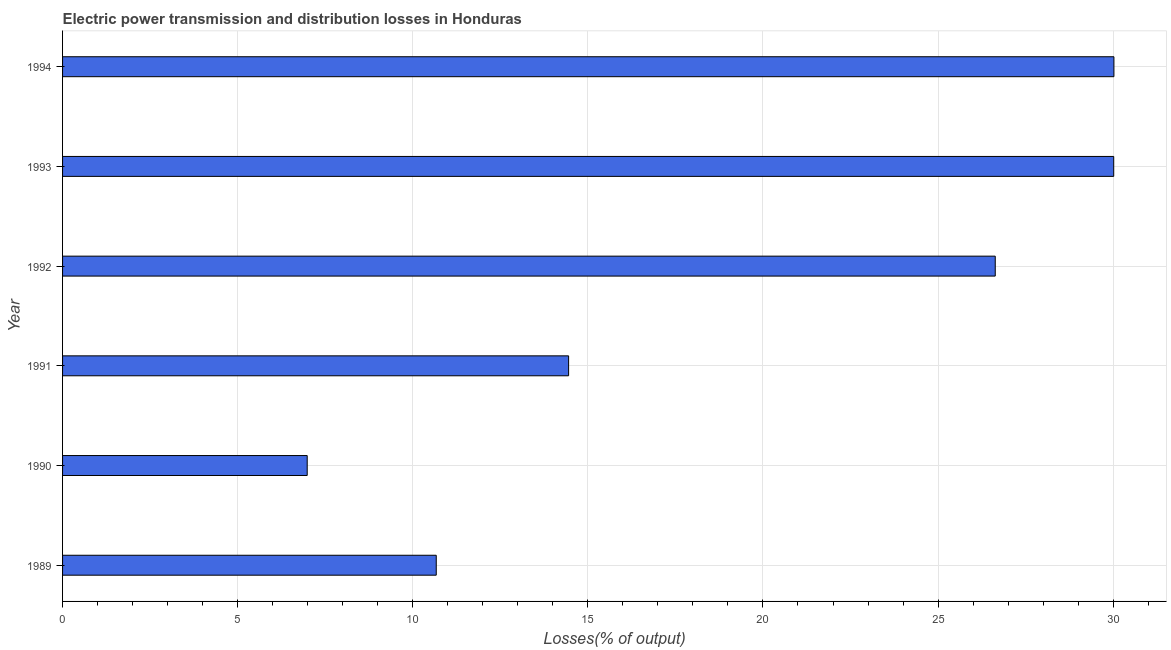Does the graph contain grids?
Offer a very short reply. Yes. What is the title of the graph?
Ensure brevity in your answer.  Electric power transmission and distribution losses in Honduras. What is the label or title of the X-axis?
Your answer should be compact. Losses(% of output). What is the label or title of the Y-axis?
Keep it short and to the point. Year. What is the electric power transmission and distribution losses in 1993?
Make the answer very short. 30.02. Across all years, what is the maximum electric power transmission and distribution losses?
Offer a very short reply. 30.02. Across all years, what is the minimum electric power transmission and distribution losses?
Give a very brief answer. 6.99. In which year was the electric power transmission and distribution losses maximum?
Your response must be concise. 1994. What is the sum of the electric power transmission and distribution losses?
Your response must be concise. 118.78. What is the difference between the electric power transmission and distribution losses in 1990 and 1994?
Your response must be concise. -23.04. What is the average electric power transmission and distribution losses per year?
Your answer should be very brief. 19.8. What is the median electric power transmission and distribution losses?
Keep it short and to the point. 20.54. In how many years, is the electric power transmission and distribution losses greater than 1 %?
Your answer should be very brief. 6. What is the ratio of the electric power transmission and distribution losses in 1991 to that in 1992?
Give a very brief answer. 0.54. Is the difference between the electric power transmission and distribution losses in 1992 and 1993 greater than the difference between any two years?
Give a very brief answer. No. What is the difference between the highest and the second highest electric power transmission and distribution losses?
Offer a terse response. 0.01. Is the sum of the electric power transmission and distribution losses in 1989 and 1994 greater than the maximum electric power transmission and distribution losses across all years?
Keep it short and to the point. Yes. What is the difference between the highest and the lowest electric power transmission and distribution losses?
Offer a terse response. 23.04. In how many years, is the electric power transmission and distribution losses greater than the average electric power transmission and distribution losses taken over all years?
Make the answer very short. 3. How many bars are there?
Keep it short and to the point. 6. Are all the bars in the graph horizontal?
Your answer should be compact. Yes. What is the difference between two consecutive major ticks on the X-axis?
Offer a very short reply. 5. What is the Losses(% of output) of 1989?
Offer a terse response. 10.67. What is the Losses(% of output) in 1990?
Keep it short and to the point. 6.99. What is the Losses(% of output) in 1991?
Offer a very short reply. 14.45. What is the Losses(% of output) of 1992?
Offer a terse response. 26.63. What is the Losses(% of output) of 1993?
Provide a succinct answer. 30.02. What is the Losses(% of output) of 1994?
Your answer should be compact. 30.02. What is the difference between the Losses(% of output) in 1989 and 1990?
Provide a short and direct response. 3.68. What is the difference between the Losses(% of output) in 1989 and 1991?
Give a very brief answer. -3.78. What is the difference between the Losses(% of output) in 1989 and 1992?
Provide a short and direct response. -15.96. What is the difference between the Losses(% of output) in 1989 and 1993?
Your answer should be compact. -19.35. What is the difference between the Losses(% of output) in 1989 and 1994?
Provide a short and direct response. -19.35. What is the difference between the Losses(% of output) in 1990 and 1991?
Your answer should be very brief. -7.46. What is the difference between the Losses(% of output) in 1990 and 1992?
Offer a terse response. -19.65. What is the difference between the Losses(% of output) in 1990 and 1993?
Make the answer very short. -23.03. What is the difference between the Losses(% of output) in 1990 and 1994?
Your answer should be very brief. -23.04. What is the difference between the Losses(% of output) in 1991 and 1992?
Your answer should be very brief. -12.18. What is the difference between the Losses(% of output) in 1991 and 1993?
Offer a terse response. -15.57. What is the difference between the Losses(% of output) in 1991 and 1994?
Give a very brief answer. -15.57. What is the difference between the Losses(% of output) in 1992 and 1993?
Offer a very short reply. -3.38. What is the difference between the Losses(% of output) in 1992 and 1994?
Provide a succinct answer. -3.39. What is the difference between the Losses(% of output) in 1993 and 1994?
Make the answer very short. -0.01. What is the ratio of the Losses(% of output) in 1989 to that in 1990?
Your response must be concise. 1.53. What is the ratio of the Losses(% of output) in 1989 to that in 1991?
Provide a short and direct response. 0.74. What is the ratio of the Losses(% of output) in 1989 to that in 1992?
Provide a short and direct response. 0.4. What is the ratio of the Losses(% of output) in 1989 to that in 1993?
Keep it short and to the point. 0.36. What is the ratio of the Losses(% of output) in 1989 to that in 1994?
Provide a short and direct response. 0.35. What is the ratio of the Losses(% of output) in 1990 to that in 1991?
Offer a terse response. 0.48. What is the ratio of the Losses(% of output) in 1990 to that in 1992?
Provide a short and direct response. 0.26. What is the ratio of the Losses(% of output) in 1990 to that in 1993?
Provide a short and direct response. 0.23. What is the ratio of the Losses(% of output) in 1990 to that in 1994?
Provide a succinct answer. 0.23. What is the ratio of the Losses(% of output) in 1991 to that in 1992?
Make the answer very short. 0.54. What is the ratio of the Losses(% of output) in 1991 to that in 1993?
Provide a short and direct response. 0.48. What is the ratio of the Losses(% of output) in 1991 to that in 1994?
Offer a terse response. 0.48. What is the ratio of the Losses(% of output) in 1992 to that in 1993?
Offer a terse response. 0.89. What is the ratio of the Losses(% of output) in 1992 to that in 1994?
Give a very brief answer. 0.89. What is the ratio of the Losses(% of output) in 1993 to that in 1994?
Give a very brief answer. 1. 